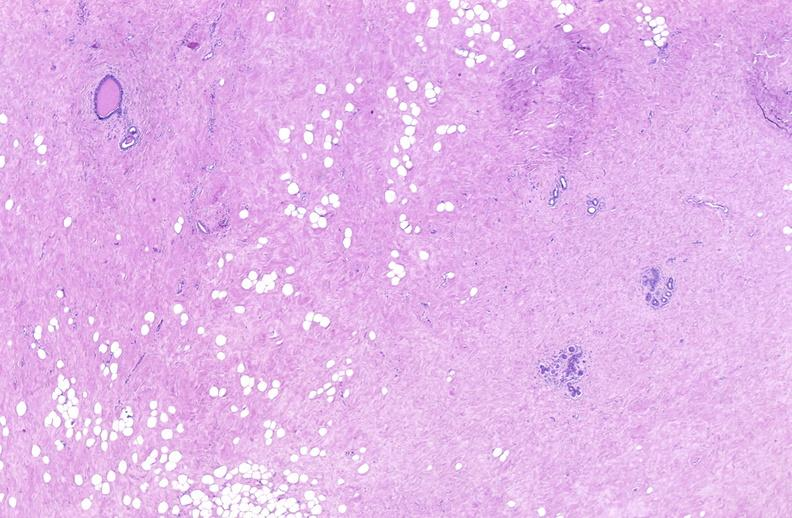where is this area in the body?
Answer the question using a single word or phrase. Breast 